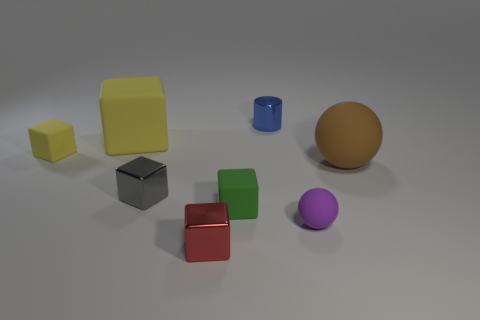Subtract all big cubes. How many cubes are left? 4 Add 2 small metal cylinders. How many objects exist? 10 Subtract all gray blocks. How many blocks are left? 4 Subtract all purple cylinders. How many yellow blocks are left? 2 Subtract all spheres. How many objects are left? 6 Subtract 1 balls. How many balls are left? 1 Subtract 0 yellow cylinders. How many objects are left? 8 Subtract all cyan cylinders. Subtract all purple balls. How many cylinders are left? 1 Subtract all green things. Subtract all large gray matte cylinders. How many objects are left? 7 Add 7 gray objects. How many gray objects are left? 8 